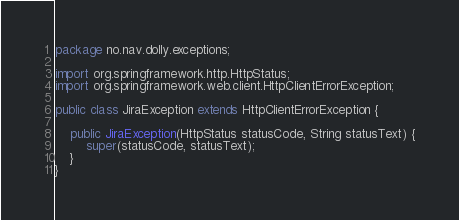<code> <loc_0><loc_0><loc_500><loc_500><_Java_>package no.nav.dolly.exceptions;

import org.springframework.http.HttpStatus;
import org.springframework.web.client.HttpClientErrorException;

public class JiraException extends HttpClientErrorException {

    public JiraException(HttpStatus statusCode, String statusText) {
        super(statusCode, statusText);
    }
}
</code> 